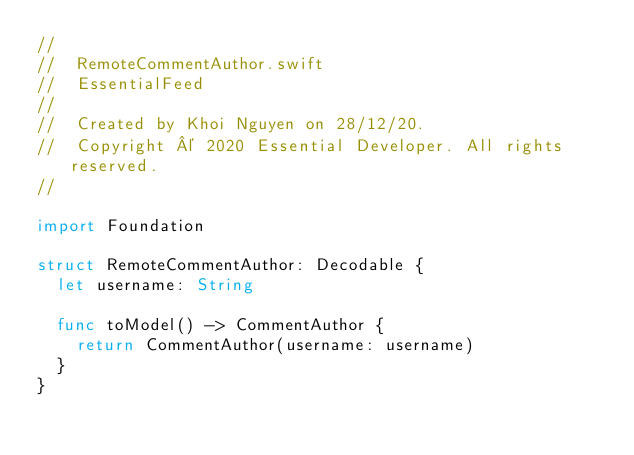Convert code to text. <code><loc_0><loc_0><loc_500><loc_500><_Swift_>//
//  RemoteCommentAuthor.swift
//  EssentialFeed
//
//  Created by Khoi Nguyen on 28/12/20.
//  Copyright © 2020 Essential Developer. All rights reserved.
//

import Foundation

struct RemoteCommentAuthor: Decodable {
	let username: String
	
	func toModel() -> CommentAuthor {
		return CommentAuthor(username: username)
	}
}
</code> 